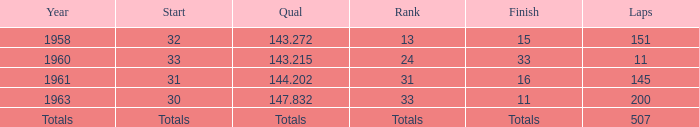In which year did the position of 31 occur? 1961.0. 